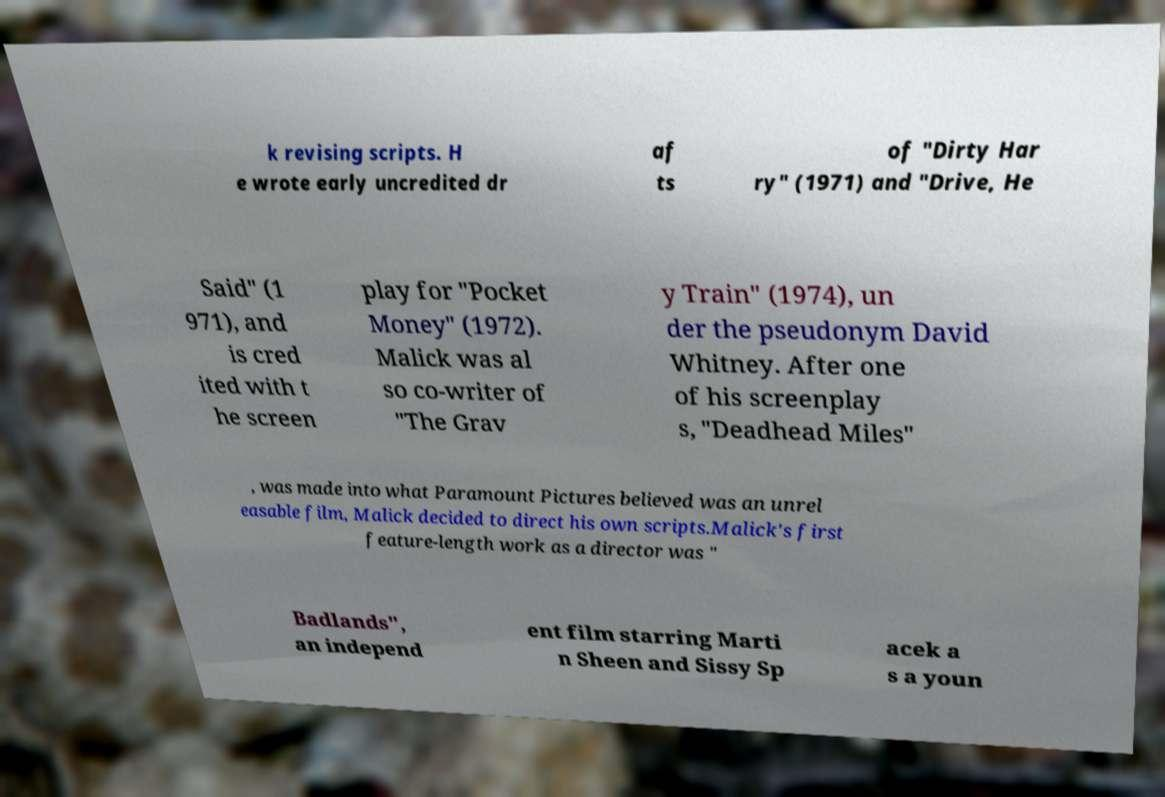There's text embedded in this image that I need extracted. Can you transcribe it verbatim? k revising scripts. H e wrote early uncredited dr af ts of "Dirty Har ry" (1971) and "Drive, He Said" (1 971), and is cred ited with t he screen play for "Pocket Money" (1972). Malick was al so co-writer of "The Grav y Train" (1974), un der the pseudonym David Whitney. After one of his screenplay s, "Deadhead Miles" , was made into what Paramount Pictures believed was an unrel easable film, Malick decided to direct his own scripts.Malick's first feature-length work as a director was " Badlands", an independ ent film starring Marti n Sheen and Sissy Sp acek a s a youn 